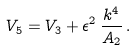<formula> <loc_0><loc_0><loc_500><loc_500>V _ { 5 } = V _ { 3 } + \epsilon ^ { 2 } \, \frac { k ^ { 4 } } { A _ { 2 } } \, .</formula> 